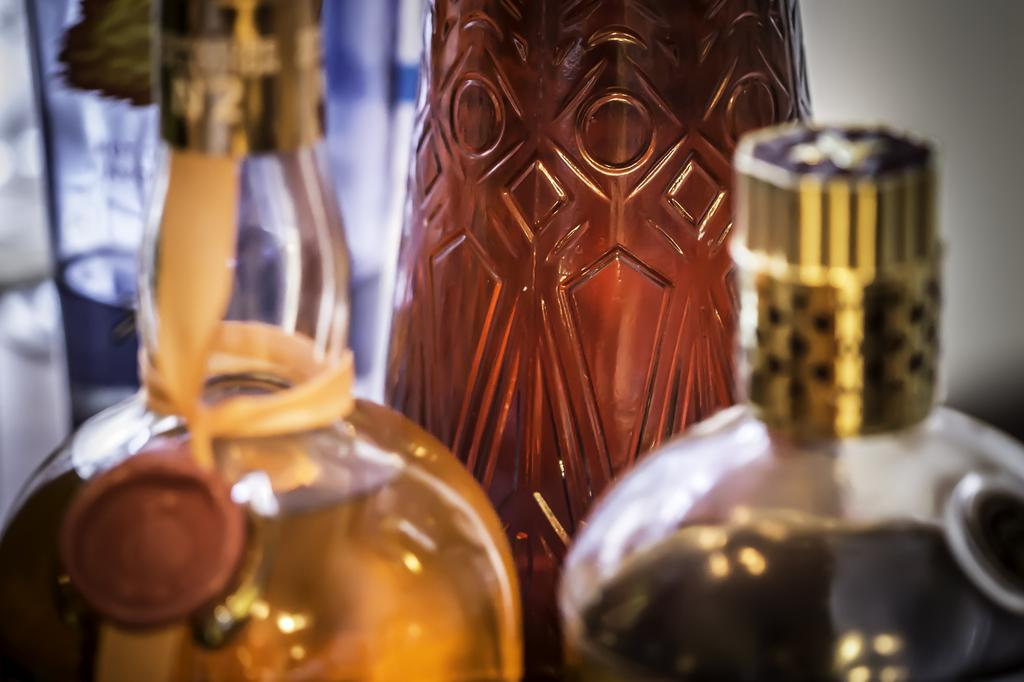How many bottles are visible in the image? There are two bottles in the image. What might be contained in the bottles? The bottles may be wine bottles. What can be seen in the background of the image? There is a wall in the background of the image. What type of theory is being discussed in the library in the image? There is no library present in the image, and therefore no theory can be discussed. 